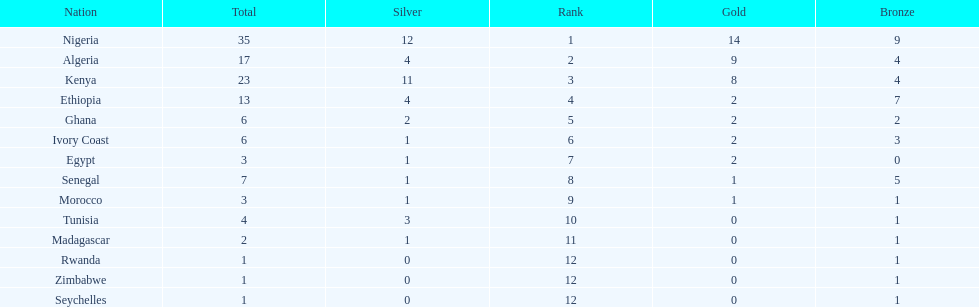The team with the most gold medals Nigeria. 